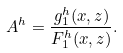Convert formula to latex. <formula><loc_0><loc_0><loc_500><loc_500>A ^ { h } = \frac { g _ { 1 } ^ { h } ( x , z ) } { F _ { 1 } ^ { h } ( x , z ) } .</formula> 